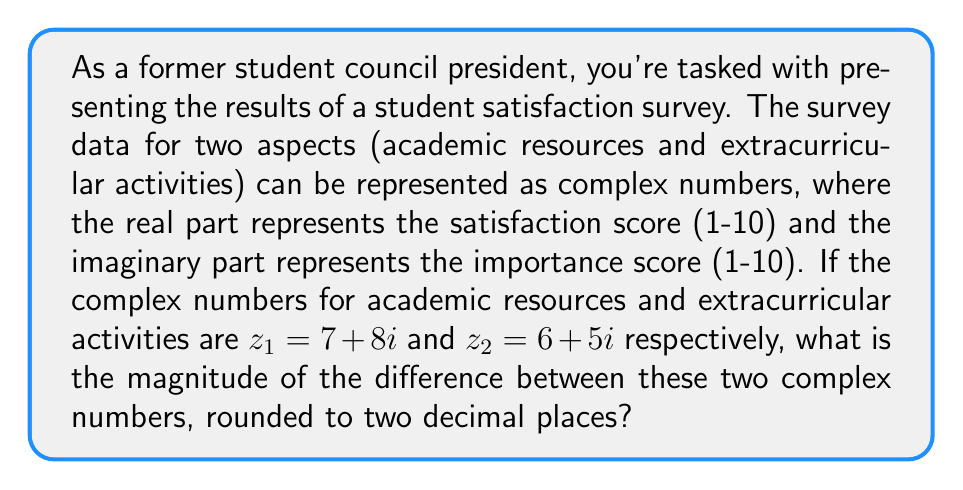Can you answer this question? Let's approach this step-by-step:

1) The difference between the two complex numbers is:
   $z_1 - z_2 = (7 + 8i) - (6 + 5i) = (7 - 6) + (8 - 5)i = 1 + 3i$

2) To find the magnitude of this difference, we use the formula:
   $|a + bi| = \sqrt{a^2 + b^2}$

3) In this case, $a = 1$ and $b = 3$, so:
   $|1 + 3i| = \sqrt{1^2 + 3^2}$

4) Simplify:
   $|1 + 3i| = \sqrt{1 + 9} = \sqrt{10}$

5) Calculate the square root:
   $\sqrt{10} \approx 3.1622776601684$

6) Rounding to two decimal places:
   $3.16$

This magnitude represents the overall difference in student satisfaction and importance between academic resources and extracurricular activities, which could be useful in prioritizing improvements in the student council report.
Answer: $3.16$ 